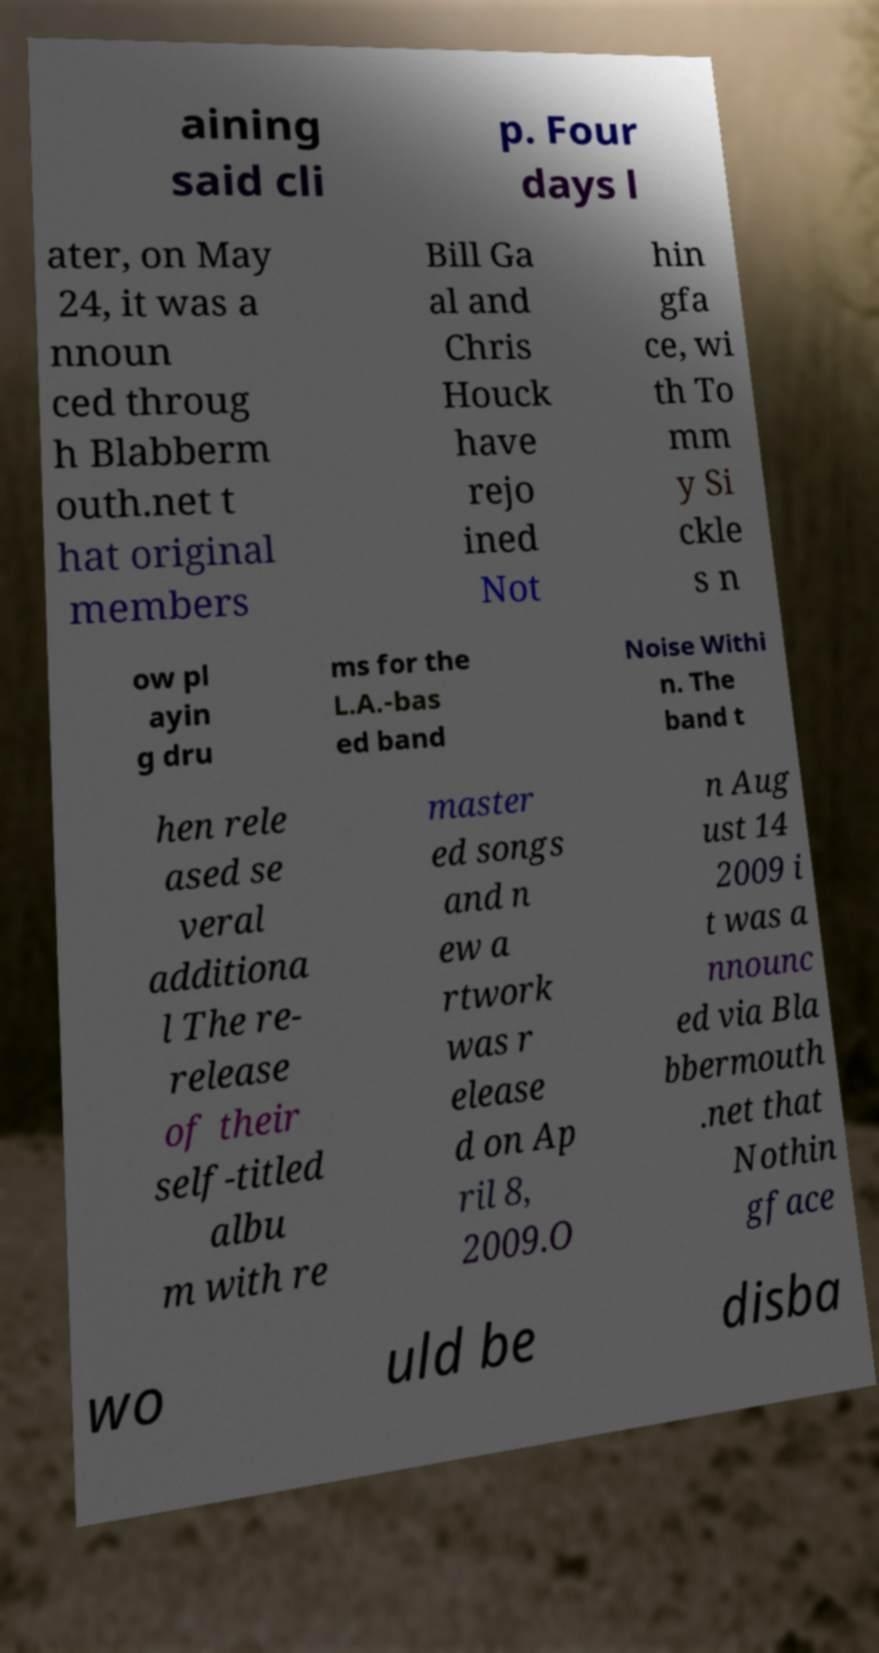What messages or text are displayed in this image? I need them in a readable, typed format. aining said cli p. Four days l ater, on May 24, it was a nnoun ced throug h Blabberm outh.net t hat original members Bill Ga al and Chris Houck have rejo ined Not hin gfa ce, wi th To mm y Si ckle s n ow pl ayin g dru ms for the L.A.-bas ed band Noise Withi n. The band t hen rele ased se veral additiona l The re- release of their self-titled albu m with re master ed songs and n ew a rtwork was r elease d on Ap ril 8, 2009.O n Aug ust 14 2009 i t was a nnounc ed via Bla bbermouth .net that Nothin gface wo uld be disba 